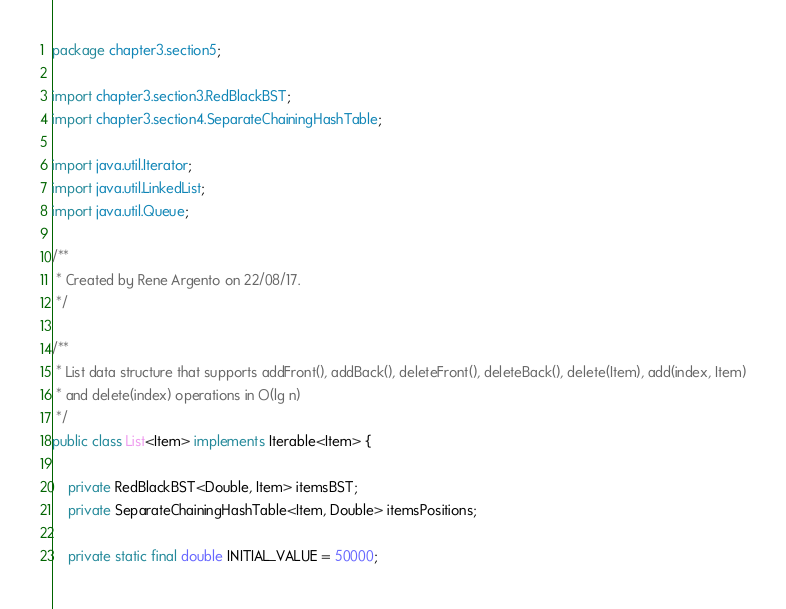Convert code to text. <code><loc_0><loc_0><loc_500><loc_500><_Java_>package chapter3.section5;

import chapter3.section3.RedBlackBST;
import chapter3.section4.SeparateChainingHashTable;

import java.util.Iterator;
import java.util.LinkedList;
import java.util.Queue;

/**
 * Created by Rene Argento on 22/08/17.
 */

/**
 * List data structure that supports addFront(), addBack(), deleteFront(), deleteBack(), delete(Item), add(index, Item)
 * and delete(index) operations in O(lg n)
 */
public class List<Item> implements Iterable<Item> {

    private RedBlackBST<Double, Item> itemsBST;
    private SeparateChainingHashTable<Item, Double> itemsPositions;

    private static final double INITIAL_VALUE = 50000;</code> 